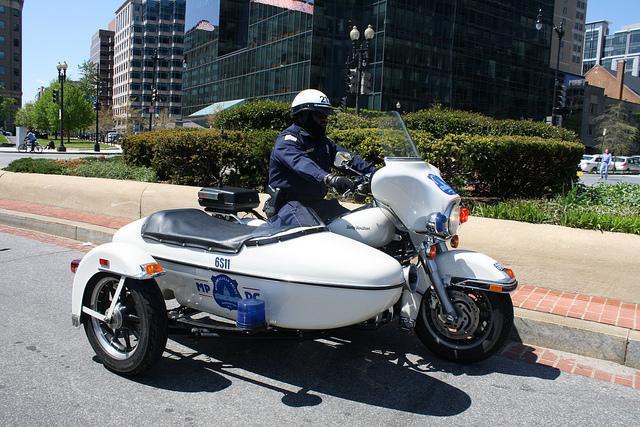How many motorcycles are there?
Give a very brief answer. 1. 